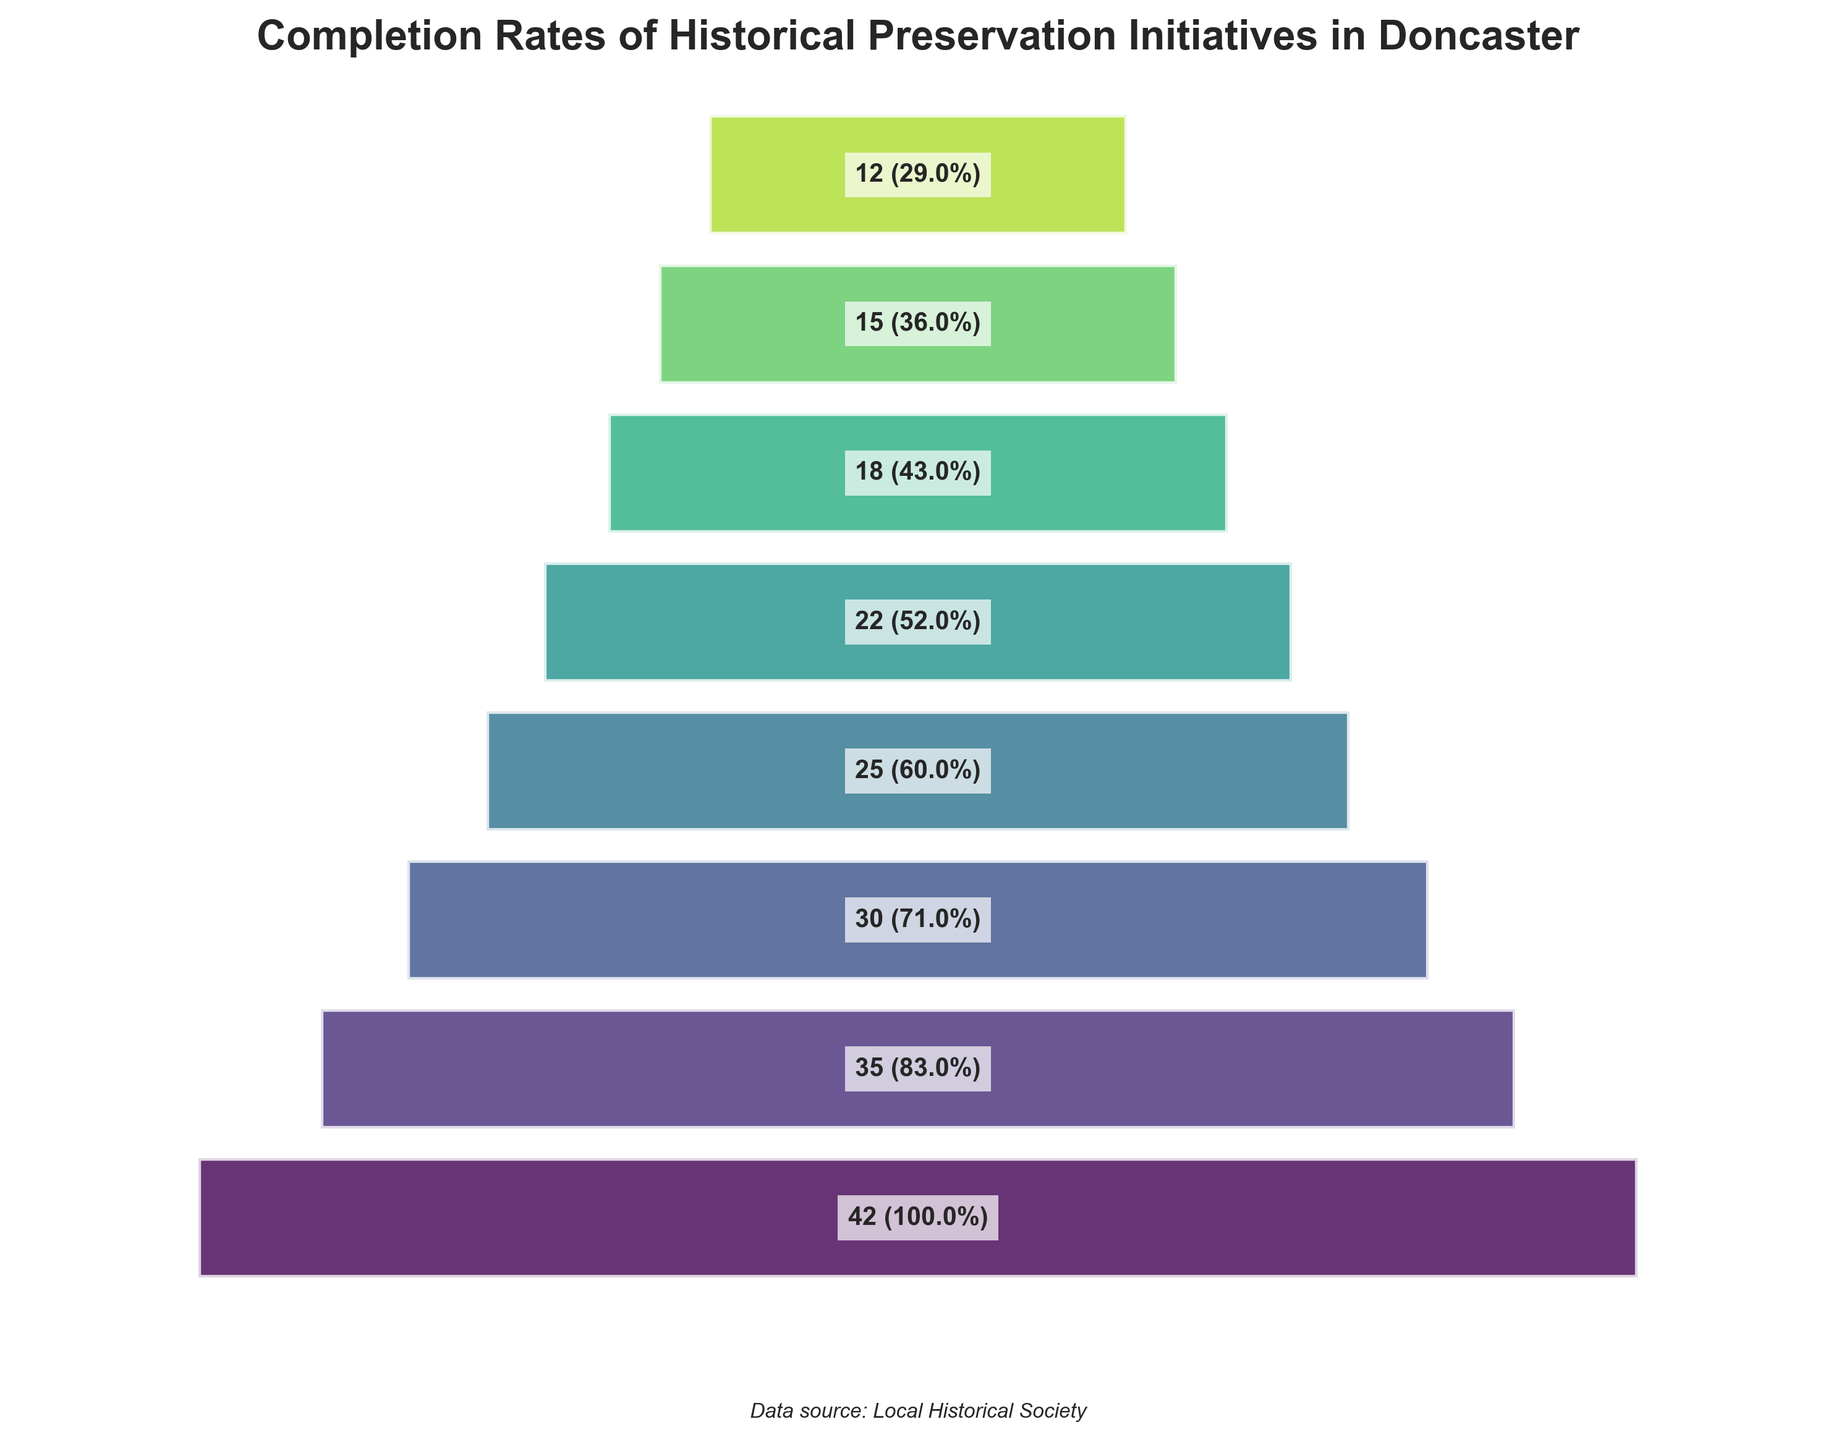Which stage has the highest completion rate? The stage with the highest completion rate is indicated by the first segment that reaches the 100% mark on the funnel.
Answer: Initial Proposal How many projects were initiated at the Initial Proposal stage? The number of projects initiated at the Initial Proposal stage is mentioned within the first segment.
Answer: 42 What is the completion rate at the Funding Secured stage? The completion rate for the Funding Secured stage is included in the text label within the corresponding segment.
Answer: 83% How many projects reach the Project Completion stage? The number of projects that reach the Project Completion stage is displayed within the final segment.
Answer: 12 Between which two consecutive stages is the biggest drop in the number of projects? To identify the biggest drop, compare the difference in the number of projects between each pair of consecutive stages. The pair with the largest difference is the answer.
Answer: Funding Secured to Planning Approved What is the sum of projects completed from the Restoration Begun stage to the Project Completion stage? Add the number of projects from the Restoration Begun (25), Structural Work Completed (22), Interior Refurbishment (18), Final Touches (15), and Project Completion (12) stages. The sum is 25 + 22 + 18 + 15 + 12 = 92.
Answer: 92 Which stage experiences the lowest completion rate? The lowest completion rate is shown at the end of the last segment labeled with the percentage.
Answer: Project Completion How many projects are left by the Interior Refurbishment stage? The number of projects left by the Interior Refurbishment stage is mentioned within the corresponding funnel segment.
Answer: 18 What is the overall percentage decrease from the Initial Proposal to the Project Completion stage? Calculate the percentage decrease: Initial Proposal (42) to Project Completion (12). The decrease is ((42 - 12) / 42) * 100 = 71.43%.
Answer: 71.43% Compare the completion rates between the Structural Work Completed and Interior Refurbishment stages. Check the completion rates for Structural Work Completed (52%) and Interior Refurbishment (43%) stages and identify which one is higher.
Answer: Structural Work Completed 